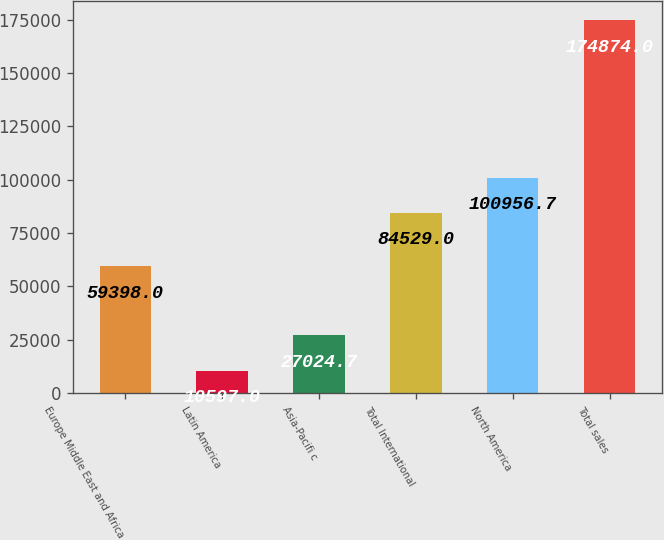<chart> <loc_0><loc_0><loc_500><loc_500><bar_chart><fcel>Europe Middle East and Africa<fcel>Latin America<fcel>Asia-Pacifi c<fcel>Total International<fcel>North America<fcel>Total sales<nl><fcel>59398<fcel>10597<fcel>27024.7<fcel>84529<fcel>100957<fcel>174874<nl></chart> 